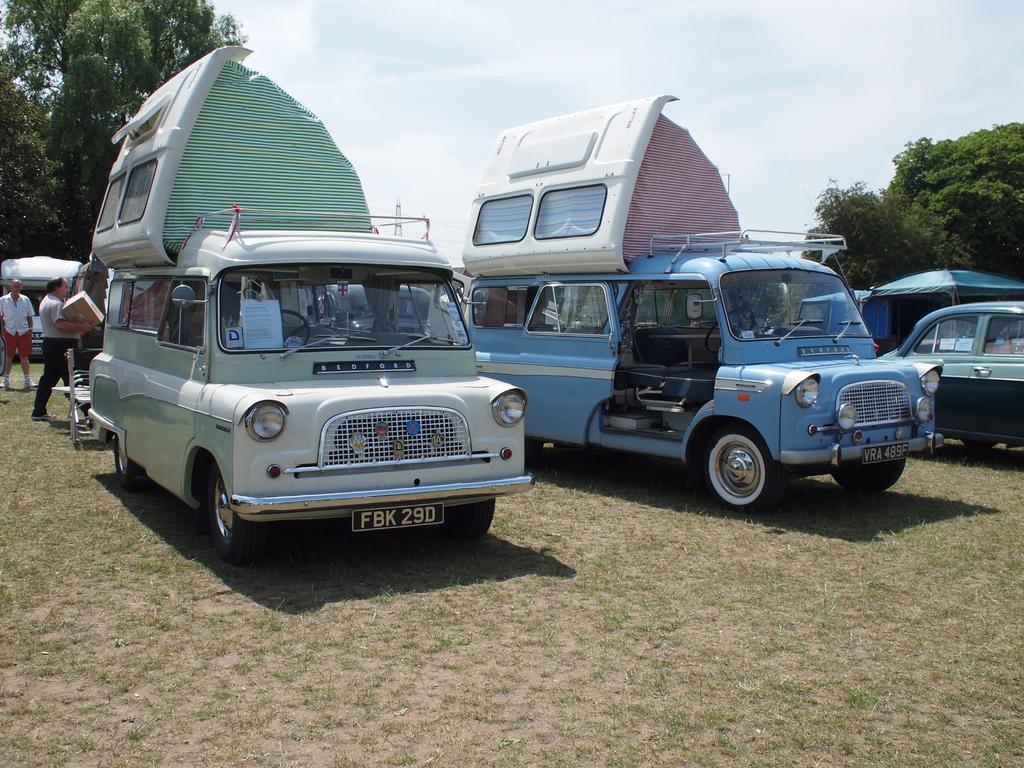How would you summarize this image in a sentence or two? In this image we can see some vehicles, persons and other objects. In the background of the image there are trees and the sky. At the bottom of the image there is the grass and ground. 